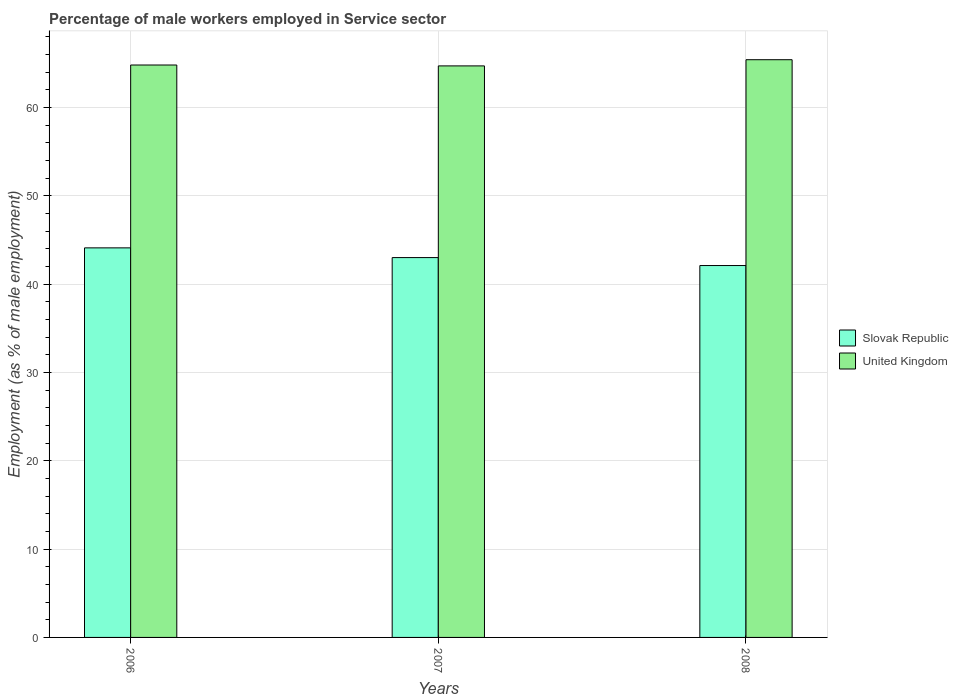Are the number of bars per tick equal to the number of legend labels?
Keep it short and to the point. Yes. Are the number of bars on each tick of the X-axis equal?
Give a very brief answer. Yes. How many bars are there on the 3rd tick from the left?
Ensure brevity in your answer.  2. How many bars are there on the 1st tick from the right?
Your answer should be compact. 2. What is the percentage of male workers employed in Service sector in Slovak Republic in 2006?
Offer a very short reply. 44.1. Across all years, what is the maximum percentage of male workers employed in Service sector in Slovak Republic?
Provide a succinct answer. 44.1. Across all years, what is the minimum percentage of male workers employed in Service sector in United Kingdom?
Ensure brevity in your answer.  64.7. What is the total percentage of male workers employed in Service sector in Slovak Republic in the graph?
Keep it short and to the point. 129.2. What is the difference between the percentage of male workers employed in Service sector in United Kingdom in 2006 and that in 2007?
Offer a very short reply. 0.1. What is the difference between the percentage of male workers employed in Service sector in United Kingdom in 2007 and the percentage of male workers employed in Service sector in Slovak Republic in 2006?
Your response must be concise. 20.6. What is the average percentage of male workers employed in Service sector in United Kingdom per year?
Provide a succinct answer. 64.97. In the year 2008, what is the difference between the percentage of male workers employed in Service sector in Slovak Republic and percentage of male workers employed in Service sector in United Kingdom?
Provide a succinct answer. -23.3. In how many years, is the percentage of male workers employed in Service sector in Slovak Republic greater than 4 %?
Provide a short and direct response. 3. What is the ratio of the percentage of male workers employed in Service sector in United Kingdom in 2006 to that in 2008?
Offer a terse response. 0.99. Is the percentage of male workers employed in Service sector in Slovak Republic in 2006 less than that in 2008?
Provide a short and direct response. No. Is the difference between the percentage of male workers employed in Service sector in Slovak Republic in 2006 and 2008 greater than the difference between the percentage of male workers employed in Service sector in United Kingdom in 2006 and 2008?
Ensure brevity in your answer.  Yes. What is the difference between the highest and the second highest percentage of male workers employed in Service sector in United Kingdom?
Your answer should be compact. 0.6. What is the difference between the highest and the lowest percentage of male workers employed in Service sector in Slovak Republic?
Ensure brevity in your answer.  2. In how many years, is the percentage of male workers employed in Service sector in United Kingdom greater than the average percentage of male workers employed in Service sector in United Kingdom taken over all years?
Offer a terse response. 1. What does the 2nd bar from the left in 2008 represents?
Your answer should be compact. United Kingdom. How many bars are there?
Offer a terse response. 6. How many years are there in the graph?
Give a very brief answer. 3. What is the difference between two consecutive major ticks on the Y-axis?
Provide a succinct answer. 10. Are the values on the major ticks of Y-axis written in scientific E-notation?
Provide a succinct answer. No. Does the graph contain any zero values?
Your answer should be compact. No. Where does the legend appear in the graph?
Offer a very short reply. Center right. How many legend labels are there?
Provide a succinct answer. 2. How are the legend labels stacked?
Offer a terse response. Vertical. What is the title of the graph?
Your answer should be compact. Percentage of male workers employed in Service sector. What is the label or title of the X-axis?
Keep it short and to the point. Years. What is the label or title of the Y-axis?
Offer a very short reply. Employment (as % of male employment). What is the Employment (as % of male employment) of Slovak Republic in 2006?
Your answer should be compact. 44.1. What is the Employment (as % of male employment) of United Kingdom in 2006?
Ensure brevity in your answer.  64.8. What is the Employment (as % of male employment) of Slovak Republic in 2007?
Provide a short and direct response. 43. What is the Employment (as % of male employment) in United Kingdom in 2007?
Provide a short and direct response. 64.7. What is the Employment (as % of male employment) in Slovak Republic in 2008?
Ensure brevity in your answer.  42.1. What is the Employment (as % of male employment) in United Kingdom in 2008?
Provide a short and direct response. 65.4. Across all years, what is the maximum Employment (as % of male employment) of Slovak Republic?
Ensure brevity in your answer.  44.1. Across all years, what is the maximum Employment (as % of male employment) in United Kingdom?
Provide a succinct answer. 65.4. Across all years, what is the minimum Employment (as % of male employment) of Slovak Republic?
Your response must be concise. 42.1. Across all years, what is the minimum Employment (as % of male employment) of United Kingdom?
Give a very brief answer. 64.7. What is the total Employment (as % of male employment) of Slovak Republic in the graph?
Your answer should be compact. 129.2. What is the total Employment (as % of male employment) in United Kingdom in the graph?
Offer a terse response. 194.9. What is the difference between the Employment (as % of male employment) of Slovak Republic in 2006 and that in 2007?
Provide a short and direct response. 1.1. What is the difference between the Employment (as % of male employment) in Slovak Republic in 2006 and that in 2008?
Provide a succinct answer. 2. What is the difference between the Employment (as % of male employment) of United Kingdom in 2006 and that in 2008?
Your answer should be compact. -0.6. What is the difference between the Employment (as % of male employment) of Slovak Republic in 2007 and that in 2008?
Offer a very short reply. 0.9. What is the difference between the Employment (as % of male employment) in Slovak Republic in 2006 and the Employment (as % of male employment) in United Kingdom in 2007?
Make the answer very short. -20.6. What is the difference between the Employment (as % of male employment) of Slovak Republic in 2006 and the Employment (as % of male employment) of United Kingdom in 2008?
Offer a terse response. -21.3. What is the difference between the Employment (as % of male employment) of Slovak Republic in 2007 and the Employment (as % of male employment) of United Kingdom in 2008?
Ensure brevity in your answer.  -22.4. What is the average Employment (as % of male employment) in Slovak Republic per year?
Ensure brevity in your answer.  43.07. What is the average Employment (as % of male employment) of United Kingdom per year?
Offer a very short reply. 64.97. In the year 2006, what is the difference between the Employment (as % of male employment) in Slovak Republic and Employment (as % of male employment) in United Kingdom?
Make the answer very short. -20.7. In the year 2007, what is the difference between the Employment (as % of male employment) of Slovak Republic and Employment (as % of male employment) of United Kingdom?
Keep it short and to the point. -21.7. In the year 2008, what is the difference between the Employment (as % of male employment) in Slovak Republic and Employment (as % of male employment) in United Kingdom?
Your response must be concise. -23.3. What is the ratio of the Employment (as % of male employment) of Slovak Republic in 2006 to that in 2007?
Offer a very short reply. 1.03. What is the ratio of the Employment (as % of male employment) of Slovak Republic in 2006 to that in 2008?
Keep it short and to the point. 1.05. What is the ratio of the Employment (as % of male employment) in Slovak Republic in 2007 to that in 2008?
Your answer should be very brief. 1.02. What is the ratio of the Employment (as % of male employment) of United Kingdom in 2007 to that in 2008?
Provide a short and direct response. 0.99. What is the difference between the highest and the second highest Employment (as % of male employment) in United Kingdom?
Your response must be concise. 0.6. What is the difference between the highest and the lowest Employment (as % of male employment) in Slovak Republic?
Provide a succinct answer. 2. What is the difference between the highest and the lowest Employment (as % of male employment) of United Kingdom?
Keep it short and to the point. 0.7. 